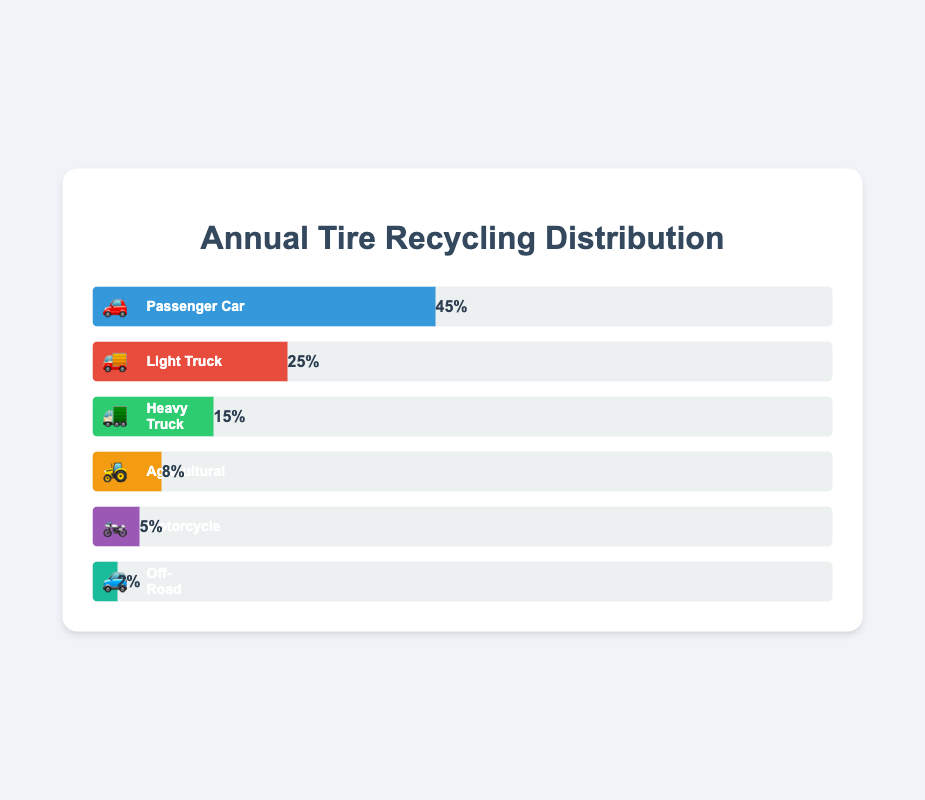What is the most recycled type of tire? The figure indicates the percentage of tire types recycled. The "Passenger Car" tire, represented by the 🚗 emoji, has the highest percentage of 45%.
Answer: Passenger Car (45%) What is the least recycled type of tire? According to the figure, the "Off-Road" tire, represented by the 🚙 emoji, has the lowest recycling percentage at 2%.
Answer: Off-Road (2%) How many types of tires have a recycling percentage above 20%? The figure shows percentages for each type: Passenger Car (45%), Light Truck (25%). Both Passenger Car and Light Truck have percentages above 20%. That's 2 tire types.
Answer: 2 Which tires combined make up more than half of the total recycled tires? Adding the percentages of the tire types with the highest values: Passenger Car (45%) + Light Truck (25%) = 70%. More than half of the recycled tires are Passenger Car and Light Truck.
Answer: Passenger Car and Light Truck How much more is the recycling percentage of Passenger Car tires compared to Heavy Truck tires? The percentages are Passenger Car (45%) and Heavy Truck (15%). The difference is 45% - 15% = 30%.
Answer: 30% What percentage of recycled tires are either Agricultural or Motorcycle types? Combining their percentages: Agricultural (8%) + Motorcycle (5%) = 13%.
Answer: 13% Which type of tire is recycled more, Heavy Truck or Agricultural? The figure shows Heavy Truck at 15% and Agricultural at 8%. Heavy Truck has a higher recycling percentage.
Answer: Heavy Truck Are Light Truck and Heavy Truck combined more recycled than Passenger Car tires? Adding their percentages: Light Truck (25%) + Heavy Truck (15%) = 40%. This is less than Passenger Car tires at 45%.
Answer: No How does the recycling percentage of Motorcycle tires compare to Off-Road tires? Motorcycle tires are 5% and Off-Road tires are 2%. Motorcycle tires have a higher percentage.
Answer: Motorcycle What percentage of tires recycled are Light Truck and Passenger Car tires together? Adding their percentages: Light Truck (25%) + Passenger Car (45%) = 70%.
Answer: 70% 